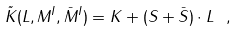<formula> <loc_0><loc_0><loc_500><loc_500>\tilde { K } ( L , M ^ { I } , \bar { M } ^ { I } ) = K + ( S + \bar { S } ) \cdot L \ ,</formula> 